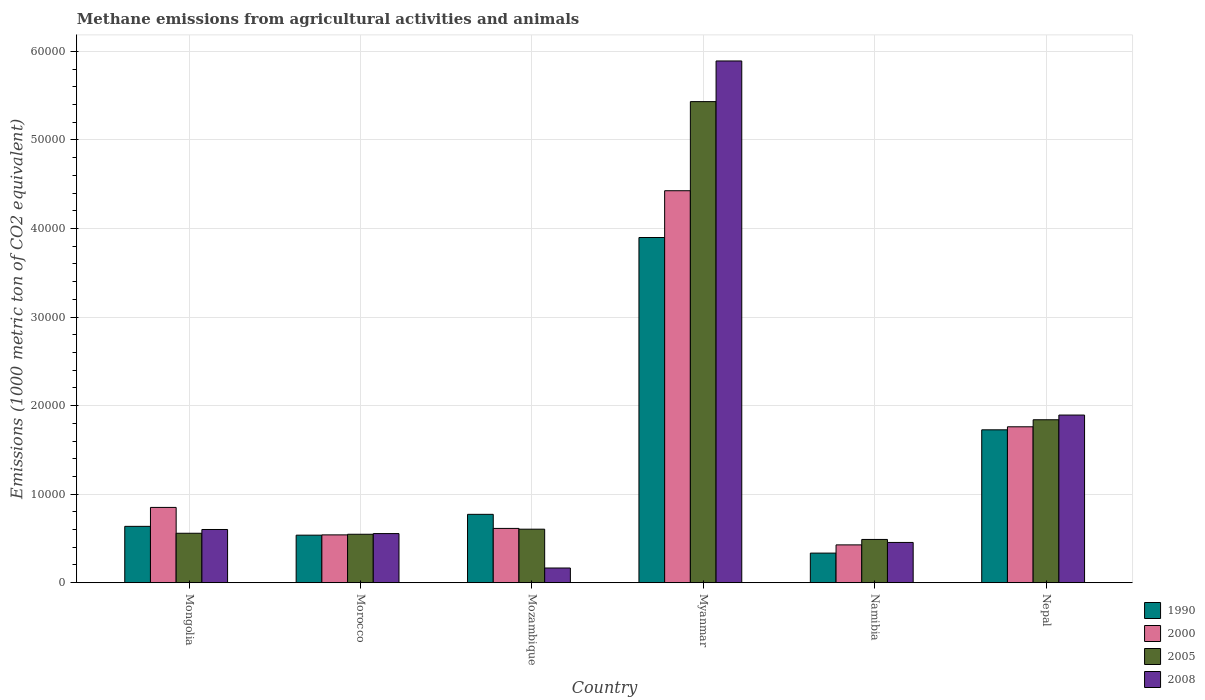How many different coloured bars are there?
Provide a succinct answer. 4. How many groups of bars are there?
Keep it short and to the point. 6. How many bars are there on the 3rd tick from the left?
Give a very brief answer. 4. What is the label of the 1st group of bars from the left?
Your response must be concise. Mongolia. What is the amount of methane emitted in 2008 in Mongolia?
Offer a terse response. 6009.3. Across all countries, what is the maximum amount of methane emitted in 2008?
Keep it short and to the point. 5.89e+04. Across all countries, what is the minimum amount of methane emitted in 1990?
Your answer should be very brief. 3344.1. In which country was the amount of methane emitted in 1990 maximum?
Your response must be concise. Myanmar. In which country was the amount of methane emitted in 1990 minimum?
Your response must be concise. Namibia. What is the total amount of methane emitted in 2000 in the graph?
Keep it short and to the point. 8.62e+04. What is the difference between the amount of methane emitted in 2005 in Morocco and that in Namibia?
Your answer should be very brief. 586. What is the difference between the amount of methane emitted in 2005 in Mongolia and the amount of methane emitted in 2000 in Myanmar?
Make the answer very short. -3.87e+04. What is the average amount of methane emitted in 1990 per country?
Keep it short and to the point. 1.32e+04. What is the difference between the amount of methane emitted of/in 2005 and amount of methane emitted of/in 1990 in Mozambique?
Provide a succinct answer. -1677.5. What is the ratio of the amount of methane emitted in 2000 in Mongolia to that in Myanmar?
Ensure brevity in your answer.  0.19. What is the difference between the highest and the second highest amount of methane emitted in 1990?
Make the answer very short. 9542.8. What is the difference between the highest and the lowest amount of methane emitted in 2008?
Provide a succinct answer. 5.73e+04. In how many countries, is the amount of methane emitted in 2008 greater than the average amount of methane emitted in 2008 taken over all countries?
Your answer should be compact. 2. Is the sum of the amount of methane emitted in 2000 in Myanmar and Nepal greater than the maximum amount of methane emitted in 1990 across all countries?
Provide a short and direct response. Yes. Is it the case that in every country, the sum of the amount of methane emitted in 2005 and amount of methane emitted in 2008 is greater than the sum of amount of methane emitted in 1990 and amount of methane emitted in 2000?
Provide a short and direct response. No. What does the 1st bar from the right in Morocco represents?
Offer a terse response. 2008. Is it the case that in every country, the sum of the amount of methane emitted in 2005 and amount of methane emitted in 1990 is greater than the amount of methane emitted in 2000?
Offer a terse response. Yes. How many bars are there?
Give a very brief answer. 24. How many countries are there in the graph?
Offer a terse response. 6. What is the difference between two consecutive major ticks on the Y-axis?
Provide a short and direct response. 10000. Does the graph contain grids?
Ensure brevity in your answer.  Yes. Where does the legend appear in the graph?
Your response must be concise. Bottom right. How are the legend labels stacked?
Keep it short and to the point. Vertical. What is the title of the graph?
Provide a succinct answer. Methane emissions from agricultural activities and animals. Does "1984" appear as one of the legend labels in the graph?
Your answer should be compact. No. What is the label or title of the X-axis?
Keep it short and to the point. Country. What is the label or title of the Y-axis?
Your response must be concise. Emissions (1000 metric ton of CO2 equivalent). What is the Emissions (1000 metric ton of CO2 equivalent) in 1990 in Mongolia?
Ensure brevity in your answer.  6363.5. What is the Emissions (1000 metric ton of CO2 equivalent) of 2000 in Mongolia?
Give a very brief answer. 8502.3. What is the Emissions (1000 metric ton of CO2 equivalent) of 2005 in Mongolia?
Your response must be concise. 5584.9. What is the Emissions (1000 metric ton of CO2 equivalent) of 2008 in Mongolia?
Provide a succinct answer. 6009.3. What is the Emissions (1000 metric ton of CO2 equivalent) in 1990 in Morocco?
Your response must be concise. 5368.8. What is the Emissions (1000 metric ton of CO2 equivalent) of 2000 in Morocco?
Keep it short and to the point. 5400.3. What is the Emissions (1000 metric ton of CO2 equivalent) in 2005 in Morocco?
Your response must be concise. 5471.4. What is the Emissions (1000 metric ton of CO2 equivalent) of 2008 in Morocco?
Keep it short and to the point. 5546.4. What is the Emissions (1000 metric ton of CO2 equivalent) of 1990 in Mozambique?
Your answer should be very brief. 7721.4. What is the Emissions (1000 metric ton of CO2 equivalent) in 2000 in Mozambique?
Provide a succinct answer. 6130.9. What is the Emissions (1000 metric ton of CO2 equivalent) in 2005 in Mozambique?
Your answer should be very brief. 6043.9. What is the Emissions (1000 metric ton of CO2 equivalent) in 2008 in Mozambique?
Make the answer very short. 1659.3. What is the Emissions (1000 metric ton of CO2 equivalent) in 1990 in Myanmar?
Make the answer very short. 3.90e+04. What is the Emissions (1000 metric ton of CO2 equivalent) of 2000 in Myanmar?
Your answer should be very brief. 4.43e+04. What is the Emissions (1000 metric ton of CO2 equivalent) in 2005 in Myanmar?
Ensure brevity in your answer.  5.43e+04. What is the Emissions (1000 metric ton of CO2 equivalent) of 2008 in Myanmar?
Offer a very short reply. 5.89e+04. What is the Emissions (1000 metric ton of CO2 equivalent) in 1990 in Namibia?
Make the answer very short. 3344.1. What is the Emissions (1000 metric ton of CO2 equivalent) of 2000 in Namibia?
Provide a short and direct response. 4271.2. What is the Emissions (1000 metric ton of CO2 equivalent) of 2005 in Namibia?
Provide a short and direct response. 4885.4. What is the Emissions (1000 metric ton of CO2 equivalent) in 2008 in Namibia?
Your answer should be compact. 4545.9. What is the Emissions (1000 metric ton of CO2 equivalent) of 1990 in Nepal?
Give a very brief answer. 1.73e+04. What is the Emissions (1000 metric ton of CO2 equivalent) of 2000 in Nepal?
Provide a succinct answer. 1.76e+04. What is the Emissions (1000 metric ton of CO2 equivalent) of 2005 in Nepal?
Ensure brevity in your answer.  1.84e+04. What is the Emissions (1000 metric ton of CO2 equivalent) of 2008 in Nepal?
Make the answer very short. 1.89e+04. Across all countries, what is the maximum Emissions (1000 metric ton of CO2 equivalent) of 1990?
Give a very brief answer. 3.90e+04. Across all countries, what is the maximum Emissions (1000 metric ton of CO2 equivalent) of 2000?
Your answer should be compact. 4.43e+04. Across all countries, what is the maximum Emissions (1000 metric ton of CO2 equivalent) of 2005?
Provide a succinct answer. 5.43e+04. Across all countries, what is the maximum Emissions (1000 metric ton of CO2 equivalent) in 2008?
Your answer should be compact. 5.89e+04. Across all countries, what is the minimum Emissions (1000 metric ton of CO2 equivalent) of 1990?
Keep it short and to the point. 3344.1. Across all countries, what is the minimum Emissions (1000 metric ton of CO2 equivalent) in 2000?
Your response must be concise. 4271.2. Across all countries, what is the minimum Emissions (1000 metric ton of CO2 equivalent) in 2005?
Keep it short and to the point. 4885.4. Across all countries, what is the minimum Emissions (1000 metric ton of CO2 equivalent) of 2008?
Offer a terse response. 1659.3. What is the total Emissions (1000 metric ton of CO2 equivalent) of 1990 in the graph?
Your answer should be compact. 7.90e+04. What is the total Emissions (1000 metric ton of CO2 equivalent) in 2000 in the graph?
Offer a very short reply. 8.62e+04. What is the total Emissions (1000 metric ton of CO2 equivalent) of 2005 in the graph?
Provide a succinct answer. 9.47e+04. What is the total Emissions (1000 metric ton of CO2 equivalent) of 2008 in the graph?
Give a very brief answer. 9.56e+04. What is the difference between the Emissions (1000 metric ton of CO2 equivalent) of 1990 in Mongolia and that in Morocco?
Your answer should be compact. 994.7. What is the difference between the Emissions (1000 metric ton of CO2 equivalent) of 2000 in Mongolia and that in Morocco?
Offer a terse response. 3102. What is the difference between the Emissions (1000 metric ton of CO2 equivalent) of 2005 in Mongolia and that in Morocco?
Ensure brevity in your answer.  113.5. What is the difference between the Emissions (1000 metric ton of CO2 equivalent) in 2008 in Mongolia and that in Morocco?
Keep it short and to the point. 462.9. What is the difference between the Emissions (1000 metric ton of CO2 equivalent) of 1990 in Mongolia and that in Mozambique?
Your answer should be very brief. -1357.9. What is the difference between the Emissions (1000 metric ton of CO2 equivalent) of 2000 in Mongolia and that in Mozambique?
Provide a short and direct response. 2371.4. What is the difference between the Emissions (1000 metric ton of CO2 equivalent) in 2005 in Mongolia and that in Mozambique?
Make the answer very short. -459. What is the difference between the Emissions (1000 metric ton of CO2 equivalent) of 2008 in Mongolia and that in Mozambique?
Your response must be concise. 4350. What is the difference between the Emissions (1000 metric ton of CO2 equivalent) in 1990 in Mongolia and that in Myanmar?
Offer a very short reply. -3.26e+04. What is the difference between the Emissions (1000 metric ton of CO2 equivalent) of 2000 in Mongolia and that in Myanmar?
Ensure brevity in your answer.  -3.58e+04. What is the difference between the Emissions (1000 metric ton of CO2 equivalent) of 2005 in Mongolia and that in Myanmar?
Give a very brief answer. -4.87e+04. What is the difference between the Emissions (1000 metric ton of CO2 equivalent) in 2008 in Mongolia and that in Myanmar?
Your answer should be compact. -5.29e+04. What is the difference between the Emissions (1000 metric ton of CO2 equivalent) of 1990 in Mongolia and that in Namibia?
Make the answer very short. 3019.4. What is the difference between the Emissions (1000 metric ton of CO2 equivalent) in 2000 in Mongolia and that in Namibia?
Your answer should be very brief. 4231.1. What is the difference between the Emissions (1000 metric ton of CO2 equivalent) in 2005 in Mongolia and that in Namibia?
Give a very brief answer. 699.5. What is the difference between the Emissions (1000 metric ton of CO2 equivalent) of 2008 in Mongolia and that in Namibia?
Offer a very short reply. 1463.4. What is the difference between the Emissions (1000 metric ton of CO2 equivalent) of 1990 in Mongolia and that in Nepal?
Your answer should be compact. -1.09e+04. What is the difference between the Emissions (1000 metric ton of CO2 equivalent) of 2000 in Mongolia and that in Nepal?
Make the answer very short. -9103.7. What is the difference between the Emissions (1000 metric ton of CO2 equivalent) in 2005 in Mongolia and that in Nepal?
Give a very brief answer. -1.28e+04. What is the difference between the Emissions (1000 metric ton of CO2 equivalent) of 2008 in Mongolia and that in Nepal?
Provide a short and direct response. -1.29e+04. What is the difference between the Emissions (1000 metric ton of CO2 equivalent) in 1990 in Morocco and that in Mozambique?
Give a very brief answer. -2352.6. What is the difference between the Emissions (1000 metric ton of CO2 equivalent) in 2000 in Morocco and that in Mozambique?
Your response must be concise. -730.6. What is the difference between the Emissions (1000 metric ton of CO2 equivalent) of 2005 in Morocco and that in Mozambique?
Your answer should be very brief. -572.5. What is the difference between the Emissions (1000 metric ton of CO2 equivalent) in 2008 in Morocco and that in Mozambique?
Your answer should be compact. 3887.1. What is the difference between the Emissions (1000 metric ton of CO2 equivalent) of 1990 in Morocco and that in Myanmar?
Provide a succinct answer. -3.36e+04. What is the difference between the Emissions (1000 metric ton of CO2 equivalent) in 2000 in Morocco and that in Myanmar?
Provide a succinct answer. -3.89e+04. What is the difference between the Emissions (1000 metric ton of CO2 equivalent) of 2005 in Morocco and that in Myanmar?
Your answer should be very brief. -4.89e+04. What is the difference between the Emissions (1000 metric ton of CO2 equivalent) of 2008 in Morocco and that in Myanmar?
Your answer should be very brief. -5.34e+04. What is the difference between the Emissions (1000 metric ton of CO2 equivalent) in 1990 in Morocco and that in Namibia?
Provide a short and direct response. 2024.7. What is the difference between the Emissions (1000 metric ton of CO2 equivalent) in 2000 in Morocco and that in Namibia?
Provide a succinct answer. 1129.1. What is the difference between the Emissions (1000 metric ton of CO2 equivalent) in 2005 in Morocco and that in Namibia?
Your answer should be very brief. 586. What is the difference between the Emissions (1000 metric ton of CO2 equivalent) of 2008 in Morocco and that in Namibia?
Your response must be concise. 1000.5. What is the difference between the Emissions (1000 metric ton of CO2 equivalent) in 1990 in Morocco and that in Nepal?
Provide a short and direct response. -1.19e+04. What is the difference between the Emissions (1000 metric ton of CO2 equivalent) in 2000 in Morocco and that in Nepal?
Ensure brevity in your answer.  -1.22e+04. What is the difference between the Emissions (1000 metric ton of CO2 equivalent) in 2005 in Morocco and that in Nepal?
Offer a terse response. -1.29e+04. What is the difference between the Emissions (1000 metric ton of CO2 equivalent) of 2008 in Morocco and that in Nepal?
Your response must be concise. -1.34e+04. What is the difference between the Emissions (1000 metric ton of CO2 equivalent) in 1990 in Mozambique and that in Myanmar?
Your response must be concise. -3.13e+04. What is the difference between the Emissions (1000 metric ton of CO2 equivalent) of 2000 in Mozambique and that in Myanmar?
Give a very brief answer. -3.81e+04. What is the difference between the Emissions (1000 metric ton of CO2 equivalent) of 2005 in Mozambique and that in Myanmar?
Give a very brief answer. -4.83e+04. What is the difference between the Emissions (1000 metric ton of CO2 equivalent) in 2008 in Mozambique and that in Myanmar?
Give a very brief answer. -5.73e+04. What is the difference between the Emissions (1000 metric ton of CO2 equivalent) in 1990 in Mozambique and that in Namibia?
Keep it short and to the point. 4377.3. What is the difference between the Emissions (1000 metric ton of CO2 equivalent) of 2000 in Mozambique and that in Namibia?
Keep it short and to the point. 1859.7. What is the difference between the Emissions (1000 metric ton of CO2 equivalent) in 2005 in Mozambique and that in Namibia?
Make the answer very short. 1158.5. What is the difference between the Emissions (1000 metric ton of CO2 equivalent) of 2008 in Mozambique and that in Namibia?
Provide a short and direct response. -2886.6. What is the difference between the Emissions (1000 metric ton of CO2 equivalent) in 1990 in Mozambique and that in Nepal?
Your answer should be compact. -9542.8. What is the difference between the Emissions (1000 metric ton of CO2 equivalent) of 2000 in Mozambique and that in Nepal?
Make the answer very short. -1.15e+04. What is the difference between the Emissions (1000 metric ton of CO2 equivalent) of 2005 in Mozambique and that in Nepal?
Your answer should be very brief. -1.24e+04. What is the difference between the Emissions (1000 metric ton of CO2 equivalent) in 2008 in Mozambique and that in Nepal?
Ensure brevity in your answer.  -1.73e+04. What is the difference between the Emissions (1000 metric ton of CO2 equivalent) in 1990 in Myanmar and that in Namibia?
Your answer should be very brief. 3.56e+04. What is the difference between the Emissions (1000 metric ton of CO2 equivalent) in 2000 in Myanmar and that in Namibia?
Ensure brevity in your answer.  4.00e+04. What is the difference between the Emissions (1000 metric ton of CO2 equivalent) of 2005 in Myanmar and that in Namibia?
Your response must be concise. 4.94e+04. What is the difference between the Emissions (1000 metric ton of CO2 equivalent) in 2008 in Myanmar and that in Namibia?
Provide a succinct answer. 5.44e+04. What is the difference between the Emissions (1000 metric ton of CO2 equivalent) of 1990 in Myanmar and that in Nepal?
Offer a very short reply. 2.17e+04. What is the difference between the Emissions (1000 metric ton of CO2 equivalent) in 2000 in Myanmar and that in Nepal?
Your response must be concise. 2.67e+04. What is the difference between the Emissions (1000 metric ton of CO2 equivalent) of 2005 in Myanmar and that in Nepal?
Keep it short and to the point. 3.59e+04. What is the difference between the Emissions (1000 metric ton of CO2 equivalent) in 2008 in Myanmar and that in Nepal?
Make the answer very short. 4.00e+04. What is the difference between the Emissions (1000 metric ton of CO2 equivalent) of 1990 in Namibia and that in Nepal?
Make the answer very short. -1.39e+04. What is the difference between the Emissions (1000 metric ton of CO2 equivalent) in 2000 in Namibia and that in Nepal?
Give a very brief answer. -1.33e+04. What is the difference between the Emissions (1000 metric ton of CO2 equivalent) in 2005 in Namibia and that in Nepal?
Provide a succinct answer. -1.35e+04. What is the difference between the Emissions (1000 metric ton of CO2 equivalent) in 2008 in Namibia and that in Nepal?
Provide a short and direct response. -1.44e+04. What is the difference between the Emissions (1000 metric ton of CO2 equivalent) in 1990 in Mongolia and the Emissions (1000 metric ton of CO2 equivalent) in 2000 in Morocco?
Your answer should be very brief. 963.2. What is the difference between the Emissions (1000 metric ton of CO2 equivalent) of 1990 in Mongolia and the Emissions (1000 metric ton of CO2 equivalent) of 2005 in Morocco?
Offer a very short reply. 892.1. What is the difference between the Emissions (1000 metric ton of CO2 equivalent) in 1990 in Mongolia and the Emissions (1000 metric ton of CO2 equivalent) in 2008 in Morocco?
Keep it short and to the point. 817.1. What is the difference between the Emissions (1000 metric ton of CO2 equivalent) of 2000 in Mongolia and the Emissions (1000 metric ton of CO2 equivalent) of 2005 in Morocco?
Offer a terse response. 3030.9. What is the difference between the Emissions (1000 metric ton of CO2 equivalent) of 2000 in Mongolia and the Emissions (1000 metric ton of CO2 equivalent) of 2008 in Morocco?
Offer a terse response. 2955.9. What is the difference between the Emissions (1000 metric ton of CO2 equivalent) of 2005 in Mongolia and the Emissions (1000 metric ton of CO2 equivalent) of 2008 in Morocco?
Your response must be concise. 38.5. What is the difference between the Emissions (1000 metric ton of CO2 equivalent) in 1990 in Mongolia and the Emissions (1000 metric ton of CO2 equivalent) in 2000 in Mozambique?
Ensure brevity in your answer.  232.6. What is the difference between the Emissions (1000 metric ton of CO2 equivalent) of 1990 in Mongolia and the Emissions (1000 metric ton of CO2 equivalent) of 2005 in Mozambique?
Your answer should be compact. 319.6. What is the difference between the Emissions (1000 metric ton of CO2 equivalent) in 1990 in Mongolia and the Emissions (1000 metric ton of CO2 equivalent) in 2008 in Mozambique?
Your answer should be very brief. 4704.2. What is the difference between the Emissions (1000 metric ton of CO2 equivalent) of 2000 in Mongolia and the Emissions (1000 metric ton of CO2 equivalent) of 2005 in Mozambique?
Provide a succinct answer. 2458.4. What is the difference between the Emissions (1000 metric ton of CO2 equivalent) in 2000 in Mongolia and the Emissions (1000 metric ton of CO2 equivalent) in 2008 in Mozambique?
Provide a short and direct response. 6843. What is the difference between the Emissions (1000 metric ton of CO2 equivalent) of 2005 in Mongolia and the Emissions (1000 metric ton of CO2 equivalent) of 2008 in Mozambique?
Your response must be concise. 3925.6. What is the difference between the Emissions (1000 metric ton of CO2 equivalent) of 1990 in Mongolia and the Emissions (1000 metric ton of CO2 equivalent) of 2000 in Myanmar?
Provide a short and direct response. -3.79e+04. What is the difference between the Emissions (1000 metric ton of CO2 equivalent) of 1990 in Mongolia and the Emissions (1000 metric ton of CO2 equivalent) of 2005 in Myanmar?
Your response must be concise. -4.80e+04. What is the difference between the Emissions (1000 metric ton of CO2 equivalent) of 1990 in Mongolia and the Emissions (1000 metric ton of CO2 equivalent) of 2008 in Myanmar?
Offer a very short reply. -5.26e+04. What is the difference between the Emissions (1000 metric ton of CO2 equivalent) in 2000 in Mongolia and the Emissions (1000 metric ton of CO2 equivalent) in 2005 in Myanmar?
Your answer should be compact. -4.58e+04. What is the difference between the Emissions (1000 metric ton of CO2 equivalent) of 2000 in Mongolia and the Emissions (1000 metric ton of CO2 equivalent) of 2008 in Myanmar?
Give a very brief answer. -5.04e+04. What is the difference between the Emissions (1000 metric ton of CO2 equivalent) in 2005 in Mongolia and the Emissions (1000 metric ton of CO2 equivalent) in 2008 in Myanmar?
Your answer should be compact. -5.33e+04. What is the difference between the Emissions (1000 metric ton of CO2 equivalent) of 1990 in Mongolia and the Emissions (1000 metric ton of CO2 equivalent) of 2000 in Namibia?
Provide a succinct answer. 2092.3. What is the difference between the Emissions (1000 metric ton of CO2 equivalent) of 1990 in Mongolia and the Emissions (1000 metric ton of CO2 equivalent) of 2005 in Namibia?
Offer a terse response. 1478.1. What is the difference between the Emissions (1000 metric ton of CO2 equivalent) of 1990 in Mongolia and the Emissions (1000 metric ton of CO2 equivalent) of 2008 in Namibia?
Make the answer very short. 1817.6. What is the difference between the Emissions (1000 metric ton of CO2 equivalent) of 2000 in Mongolia and the Emissions (1000 metric ton of CO2 equivalent) of 2005 in Namibia?
Offer a very short reply. 3616.9. What is the difference between the Emissions (1000 metric ton of CO2 equivalent) of 2000 in Mongolia and the Emissions (1000 metric ton of CO2 equivalent) of 2008 in Namibia?
Keep it short and to the point. 3956.4. What is the difference between the Emissions (1000 metric ton of CO2 equivalent) in 2005 in Mongolia and the Emissions (1000 metric ton of CO2 equivalent) in 2008 in Namibia?
Provide a short and direct response. 1039. What is the difference between the Emissions (1000 metric ton of CO2 equivalent) of 1990 in Mongolia and the Emissions (1000 metric ton of CO2 equivalent) of 2000 in Nepal?
Keep it short and to the point. -1.12e+04. What is the difference between the Emissions (1000 metric ton of CO2 equivalent) in 1990 in Mongolia and the Emissions (1000 metric ton of CO2 equivalent) in 2005 in Nepal?
Ensure brevity in your answer.  -1.20e+04. What is the difference between the Emissions (1000 metric ton of CO2 equivalent) in 1990 in Mongolia and the Emissions (1000 metric ton of CO2 equivalent) in 2008 in Nepal?
Your answer should be compact. -1.26e+04. What is the difference between the Emissions (1000 metric ton of CO2 equivalent) in 2000 in Mongolia and the Emissions (1000 metric ton of CO2 equivalent) in 2005 in Nepal?
Keep it short and to the point. -9897. What is the difference between the Emissions (1000 metric ton of CO2 equivalent) of 2000 in Mongolia and the Emissions (1000 metric ton of CO2 equivalent) of 2008 in Nepal?
Offer a very short reply. -1.04e+04. What is the difference between the Emissions (1000 metric ton of CO2 equivalent) in 2005 in Mongolia and the Emissions (1000 metric ton of CO2 equivalent) in 2008 in Nepal?
Keep it short and to the point. -1.33e+04. What is the difference between the Emissions (1000 metric ton of CO2 equivalent) in 1990 in Morocco and the Emissions (1000 metric ton of CO2 equivalent) in 2000 in Mozambique?
Provide a succinct answer. -762.1. What is the difference between the Emissions (1000 metric ton of CO2 equivalent) in 1990 in Morocco and the Emissions (1000 metric ton of CO2 equivalent) in 2005 in Mozambique?
Your answer should be compact. -675.1. What is the difference between the Emissions (1000 metric ton of CO2 equivalent) of 1990 in Morocco and the Emissions (1000 metric ton of CO2 equivalent) of 2008 in Mozambique?
Ensure brevity in your answer.  3709.5. What is the difference between the Emissions (1000 metric ton of CO2 equivalent) of 2000 in Morocco and the Emissions (1000 metric ton of CO2 equivalent) of 2005 in Mozambique?
Your answer should be very brief. -643.6. What is the difference between the Emissions (1000 metric ton of CO2 equivalent) of 2000 in Morocco and the Emissions (1000 metric ton of CO2 equivalent) of 2008 in Mozambique?
Provide a short and direct response. 3741. What is the difference between the Emissions (1000 metric ton of CO2 equivalent) in 2005 in Morocco and the Emissions (1000 metric ton of CO2 equivalent) in 2008 in Mozambique?
Provide a short and direct response. 3812.1. What is the difference between the Emissions (1000 metric ton of CO2 equivalent) in 1990 in Morocco and the Emissions (1000 metric ton of CO2 equivalent) in 2000 in Myanmar?
Ensure brevity in your answer.  -3.89e+04. What is the difference between the Emissions (1000 metric ton of CO2 equivalent) of 1990 in Morocco and the Emissions (1000 metric ton of CO2 equivalent) of 2005 in Myanmar?
Your answer should be very brief. -4.90e+04. What is the difference between the Emissions (1000 metric ton of CO2 equivalent) in 1990 in Morocco and the Emissions (1000 metric ton of CO2 equivalent) in 2008 in Myanmar?
Provide a succinct answer. -5.35e+04. What is the difference between the Emissions (1000 metric ton of CO2 equivalent) of 2000 in Morocco and the Emissions (1000 metric ton of CO2 equivalent) of 2005 in Myanmar?
Your answer should be compact. -4.89e+04. What is the difference between the Emissions (1000 metric ton of CO2 equivalent) of 2000 in Morocco and the Emissions (1000 metric ton of CO2 equivalent) of 2008 in Myanmar?
Provide a succinct answer. -5.35e+04. What is the difference between the Emissions (1000 metric ton of CO2 equivalent) of 2005 in Morocco and the Emissions (1000 metric ton of CO2 equivalent) of 2008 in Myanmar?
Provide a short and direct response. -5.34e+04. What is the difference between the Emissions (1000 metric ton of CO2 equivalent) in 1990 in Morocco and the Emissions (1000 metric ton of CO2 equivalent) in 2000 in Namibia?
Provide a short and direct response. 1097.6. What is the difference between the Emissions (1000 metric ton of CO2 equivalent) of 1990 in Morocco and the Emissions (1000 metric ton of CO2 equivalent) of 2005 in Namibia?
Your answer should be very brief. 483.4. What is the difference between the Emissions (1000 metric ton of CO2 equivalent) of 1990 in Morocco and the Emissions (1000 metric ton of CO2 equivalent) of 2008 in Namibia?
Keep it short and to the point. 822.9. What is the difference between the Emissions (1000 metric ton of CO2 equivalent) in 2000 in Morocco and the Emissions (1000 metric ton of CO2 equivalent) in 2005 in Namibia?
Keep it short and to the point. 514.9. What is the difference between the Emissions (1000 metric ton of CO2 equivalent) of 2000 in Morocco and the Emissions (1000 metric ton of CO2 equivalent) of 2008 in Namibia?
Your response must be concise. 854.4. What is the difference between the Emissions (1000 metric ton of CO2 equivalent) in 2005 in Morocco and the Emissions (1000 metric ton of CO2 equivalent) in 2008 in Namibia?
Give a very brief answer. 925.5. What is the difference between the Emissions (1000 metric ton of CO2 equivalent) of 1990 in Morocco and the Emissions (1000 metric ton of CO2 equivalent) of 2000 in Nepal?
Offer a very short reply. -1.22e+04. What is the difference between the Emissions (1000 metric ton of CO2 equivalent) in 1990 in Morocco and the Emissions (1000 metric ton of CO2 equivalent) in 2005 in Nepal?
Provide a succinct answer. -1.30e+04. What is the difference between the Emissions (1000 metric ton of CO2 equivalent) of 1990 in Morocco and the Emissions (1000 metric ton of CO2 equivalent) of 2008 in Nepal?
Keep it short and to the point. -1.36e+04. What is the difference between the Emissions (1000 metric ton of CO2 equivalent) of 2000 in Morocco and the Emissions (1000 metric ton of CO2 equivalent) of 2005 in Nepal?
Provide a short and direct response. -1.30e+04. What is the difference between the Emissions (1000 metric ton of CO2 equivalent) in 2000 in Morocco and the Emissions (1000 metric ton of CO2 equivalent) in 2008 in Nepal?
Provide a succinct answer. -1.35e+04. What is the difference between the Emissions (1000 metric ton of CO2 equivalent) in 2005 in Morocco and the Emissions (1000 metric ton of CO2 equivalent) in 2008 in Nepal?
Your response must be concise. -1.35e+04. What is the difference between the Emissions (1000 metric ton of CO2 equivalent) of 1990 in Mozambique and the Emissions (1000 metric ton of CO2 equivalent) of 2000 in Myanmar?
Ensure brevity in your answer.  -3.65e+04. What is the difference between the Emissions (1000 metric ton of CO2 equivalent) in 1990 in Mozambique and the Emissions (1000 metric ton of CO2 equivalent) in 2005 in Myanmar?
Offer a very short reply. -4.66e+04. What is the difference between the Emissions (1000 metric ton of CO2 equivalent) in 1990 in Mozambique and the Emissions (1000 metric ton of CO2 equivalent) in 2008 in Myanmar?
Offer a very short reply. -5.12e+04. What is the difference between the Emissions (1000 metric ton of CO2 equivalent) in 2000 in Mozambique and the Emissions (1000 metric ton of CO2 equivalent) in 2005 in Myanmar?
Your answer should be compact. -4.82e+04. What is the difference between the Emissions (1000 metric ton of CO2 equivalent) of 2000 in Mozambique and the Emissions (1000 metric ton of CO2 equivalent) of 2008 in Myanmar?
Give a very brief answer. -5.28e+04. What is the difference between the Emissions (1000 metric ton of CO2 equivalent) in 2005 in Mozambique and the Emissions (1000 metric ton of CO2 equivalent) in 2008 in Myanmar?
Give a very brief answer. -5.29e+04. What is the difference between the Emissions (1000 metric ton of CO2 equivalent) in 1990 in Mozambique and the Emissions (1000 metric ton of CO2 equivalent) in 2000 in Namibia?
Provide a short and direct response. 3450.2. What is the difference between the Emissions (1000 metric ton of CO2 equivalent) of 1990 in Mozambique and the Emissions (1000 metric ton of CO2 equivalent) of 2005 in Namibia?
Provide a succinct answer. 2836. What is the difference between the Emissions (1000 metric ton of CO2 equivalent) of 1990 in Mozambique and the Emissions (1000 metric ton of CO2 equivalent) of 2008 in Namibia?
Offer a terse response. 3175.5. What is the difference between the Emissions (1000 metric ton of CO2 equivalent) of 2000 in Mozambique and the Emissions (1000 metric ton of CO2 equivalent) of 2005 in Namibia?
Your answer should be compact. 1245.5. What is the difference between the Emissions (1000 metric ton of CO2 equivalent) in 2000 in Mozambique and the Emissions (1000 metric ton of CO2 equivalent) in 2008 in Namibia?
Your answer should be compact. 1585. What is the difference between the Emissions (1000 metric ton of CO2 equivalent) of 2005 in Mozambique and the Emissions (1000 metric ton of CO2 equivalent) of 2008 in Namibia?
Give a very brief answer. 1498. What is the difference between the Emissions (1000 metric ton of CO2 equivalent) of 1990 in Mozambique and the Emissions (1000 metric ton of CO2 equivalent) of 2000 in Nepal?
Offer a terse response. -9884.6. What is the difference between the Emissions (1000 metric ton of CO2 equivalent) of 1990 in Mozambique and the Emissions (1000 metric ton of CO2 equivalent) of 2005 in Nepal?
Offer a terse response. -1.07e+04. What is the difference between the Emissions (1000 metric ton of CO2 equivalent) in 1990 in Mozambique and the Emissions (1000 metric ton of CO2 equivalent) in 2008 in Nepal?
Keep it short and to the point. -1.12e+04. What is the difference between the Emissions (1000 metric ton of CO2 equivalent) of 2000 in Mozambique and the Emissions (1000 metric ton of CO2 equivalent) of 2005 in Nepal?
Offer a terse response. -1.23e+04. What is the difference between the Emissions (1000 metric ton of CO2 equivalent) in 2000 in Mozambique and the Emissions (1000 metric ton of CO2 equivalent) in 2008 in Nepal?
Provide a succinct answer. -1.28e+04. What is the difference between the Emissions (1000 metric ton of CO2 equivalent) in 2005 in Mozambique and the Emissions (1000 metric ton of CO2 equivalent) in 2008 in Nepal?
Make the answer very short. -1.29e+04. What is the difference between the Emissions (1000 metric ton of CO2 equivalent) of 1990 in Myanmar and the Emissions (1000 metric ton of CO2 equivalent) of 2000 in Namibia?
Provide a succinct answer. 3.47e+04. What is the difference between the Emissions (1000 metric ton of CO2 equivalent) of 1990 in Myanmar and the Emissions (1000 metric ton of CO2 equivalent) of 2005 in Namibia?
Ensure brevity in your answer.  3.41e+04. What is the difference between the Emissions (1000 metric ton of CO2 equivalent) of 1990 in Myanmar and the Emissions (1000 metric ton of CO2 equivalent) of 2008 in Namibia?
Offer a very short reply. 3.44e+04. What is the difference between the Emissions (1000 metric ton of CO2 equivalent) in 2000 in Myanmar and the Emissions (1000 metric ton of CO2 equivalent) in 2005 in Namibia?
Ensure brevity in your answer.  3.94e+04. What is the difference between the Emissions (1000 metric ton of CO2 equivalent) of 2000 in Myanmar and the Emissions (1000 metric ton of CO2 equivalent) of 2008 in Namibia?
Provide a short and direct response. 3.97e+04. What is the difference between the Emissions (1000 metric ton of CO2 equivalent) in 2005 in Myanmar and the Emissions (1000 metric ton of CO2 equivalent) in 2008 in Namibia?
Your answer should be compact. 4.98e+04. What is the difference between the Emissions (1000 metric ton of CO2 equivalent) in 1990 in Myanmar and the Emissions (1000 metric ton of CO2 equivalent) in 2000 in Nepal?
Make the answer very short. 2.14e+04. What is the difference between the Emissions (1000 metric ton of CO2 equivalent) of 1990 in Myanmar and the Emissions (1000 metric ton of CO2 equivalent) of 2005 in Nepal?
Give a very brief answer. 2.06e+04. What is the difference between the Emissions (1000 metric ton of CO2 equivalent) of 1990 in Myanmar and the Emissions (1000 metric ton of CO2 equivalent) of 2008 in Nepal?
Your answer should be compact. 2.00e+04. What is the difference between the Emissions (1000 metric ton of CO2 equivalent) in 2000 in Myanmar and the Emissions (1000 metric ton of CO2 equivalent) in 2005 in Nepal?
Give a very brief answer. 2.59e+04. What is the difference between the Emissions (1000 metric ton of CO2 equivalent) in 2000 in Myanmar and the Emissions (1000 metric ton of CO2 equivalent) in 2008 in Nepal?
Provide a short and direct response. 2.53e+04. What is the difference between the Emissions (1000 metric ton of CO2 equivalent) in 2005 in Myanmar and the Emissions (1000 metric ton of CO2 equivalent) in 2008 in Nepal?
Provide a short and direct response. 3.54e+04. What is the difference between the Emissions (1000 metric ton of CO2 equivalent) in 1990 in Namibia and the Emissions (1000 metric ton of CO2 equivalent) in 2000 in Nepal?
Your answer should be compact. -1.43e+04. What is the difference between the Emissions (1000 metric ton of CO2 equivalent) in 1990 in Namibia and the Emissions (1000 metric ton of CO2 equivalent) in 2005 in Nepal?
Give a very brief answer. -1.51e+04. What is the difference between the Emissions (1000 metric ton of CO2 equivalent) of 1990 in Namibia and the Emissions (1000 metric ton of CO2 equivalent) of 2008 in Nepal?
Offer a terse response. -1.56e+04. What is the difference between the Emissions (1000 metric ton of CO2 equivalent) of 2000 in Namibia and the Emissions (1000 metric ton of CO2 equivalent) of 2005 in Nepal?
Make the answer very short. -1.41e+04. What is the difference between the Emissions (1000 metric ton of CO2 equivalent) in 2000 in Namibia and the Emissions (1000 metric ton of CO2 equivalent) in 2008 in Nepal?
Your response must be concise. -1.47e+04. What is the difference between the Emissions (1000 metric ton of CO2 equivalent) in 2005 in Namibia and the Emissions (1000 metric ton of CO2 equivalent) in 2008 in Nepal?
Provide a succinct answer. -1.40e+04. What is the average Emissions (1000 metric ton of CO2 equivalent) in 1990 per country?
Keep it short and to the point. 1.32e+04. What is the average Emissions (1000 metric ton of CO2 equivalent) of 2000 per country?
Offer a very short reply. 1.44e+04. What is the average Emissions (1000 metric ton of CO2 equivalent) of 2005 per country?
Your answer should be very brief. 1.58e+04. What is the average Emissions (1000 metric ton of CO2 equivalent) in 2008 per country?
Make the answer very short. 1.59e+04. What is the difference between the Emissions (1000 metric ton of CO2 equivalent) in 1990 and Emissions (1000 metric ton of CO2 equivalent) in 2000 in Mongolia?
Your response must be concise. -2138.8. What is the difference between the Emissions (1000 metric ton of CO2 equivalent) of 1990 and Emissions (1000 metric ton of CO2 equivalent) of 2005 in Mongolia?
Your answer should be very brief. 778.6. What is the difference between the Emissions (1000 metric ton of CO2 equivalent) of 1990 and Emissions (1000 metric ton of CO2 equivalent) of 2008 in Mongolia?
Provide a short and direct response. 354.2. What is the difference between the Emissions (1000 metric ton of CO2 equivalent) in 2000 and Emissions (1000 metric ton of CO2 equivalent) in 2005 in Mongolia?
Your answer should be very brief. 2917.4. What is the difference between the Emissions (1000 metric ton of CO2 equivalent) of 2000 and Emissions (1000 metric ton of CO2 equivalent) of 2008 in Mongolia?
Provide a succinct answer. 2493. What is the difference between the Emissions (1000 metric ton of CO2 equivalent) in 2005 and Emissions (1000 metric ton of CO2 equivalent) in 2008 in Mongolia?
Give a very brief answer. -424.4. What is the difference between the Emissions (1000 metric ton of CO2 equivalent) in 1990 and Emissions (1000 metric ton of CO2 equivalent) in 2000 in Morocco?
Your answer should be very brief. -31.5. What is the difference between the Emissions (1000 metric ton of CO2 equivalent) in 1990 and Emissions (1000 metric ton of CO2 equivalent) in 2005 in Morocco?
Provide a succinct answer. -102.6. What is the difference between the Emissions (1000 metric ton of CO2 equivalent) in 1990 and Emissions (1000 metric ton of CO2 equivalent) in 2008 in Morocco?
Your response must be concise. -177.6. What is the difference between the Emissions (1000 metric ton of CO2 equivalent) of 2000 and Emissions (1000 metric ton of CO2 equivalent) of 2005 in Morocco?
Ensure brevity in your answer.  -71.1. What is the difference between the Emissions (1000 metric ton of CO2 equivalent) of 2000 and Emissions (1000 metric ton of CO2 equivalent) of 2008 in Morocco?
Offer a very short reply. -146.1. What is the difference between the Emissions (1000 metric ton of CO2 equivalent) of 2005 and Emissions (1000 metric ton of CO2 equivalent) of 2008 in Morocco?
Offer a very short reply. -75. What is the difference between the Emissions (1000 metric ton of CO2 equivalent) in 1990 and Emissions (1000 metric ton of CO2 equivalent) in 2000 in Mozambique?
Your answer should be compact. 1590.5. What is the difference between the Emissions (1000 metric ton of CO2 equivalent) in 1990 and Emissions (1000 metric ton of CO2 equivalent) in 2005 in Mozambique?
Keep it short and to the point. 1677.5. What is the difference between the Emissions (1000 metric ton of CO2 equivalent) in 1990 and Emissions (1000 metric ton of CO2 equivalent) in 2008 in Mozambique?
Make the answer very short. 6062.1. What is the difference between the Emissions (1000 metric ton of CO2 equivalent) in 2000 and Emissions (1000 metric ton of CO2 equivalent) in 2008 in Mozambique?
Give a very brief answer. 4471.6. What is the difference between the Emissions (1000 metric ton of CO2 equivalent) in 2005 and Emissions (1000 metric ton of CO2 equivalent) in 2008 in Mozambique?
Provide a succinct answer. 4384.6. What is the difference between the Emissions (1000 metric ton of CO2 equivalent) of 1990 and Emissions (1000 metric ton of CO2 equivalent) of 2000 in Myanmar?
Ensure brevity in your answer.  -5282. What is the difference between the Emissions (1000 metric ton of CO2 equivalent) of 1990 and Emissions (1000 metric ton of CO2 equivalent) of 2005 in Myanmar?
Keep it short and to the point. -1.53e+04. What is the difference between the Emissions (1000 metric ton of CO2 equivalent) in 1990 and Emissions (1000 metric ton of CO2 equivalent) in 2008 in Myanmar?
Your answer should be very brief. -1.99e+04. What is the difference between the Emissions (1000 metric ton of CO2 equivalent) of 2000 and Emissions (1000 metric ton of CO2 equivalent) of 2005 in Myanmar?
Your answer should be compact. -1.01e+04. What is the difference between the Emissions (1000 metric ton of CO2 equivalent) in 2000 and Emissions (1000 metric ton of CO2 equivalent) in 2008 in Myanmar?
Give a very brief answer. -1.47e+04. What is the difference between the Emissions (1000 metric ton of CO2 equivalent) in 2005 and Emissions (1000 metric ton of CO2 equivalent) in 2008 in Myanmar?
Ensure brevity in your answer.  -4589.9. What is the difference between the Emissions (1000 metric ton of CO2 equivalent) in 1990 and Emissions (1000 metric ton of CO2 equivalent) in 2000 in Namibia?
Offer a very short reply. -927.1. What is the difference between the Emissions (1000 metric ton of CO2 equivalent) in 1990 and Emissions (1000 metric ton of CO2 equivalent) in 2005 in Namibia?
Make the answer very short. -1541.3. What is the difference between the Emissions (1000 metric ton of CO2 equivalent) in 1990 and Emissions (1000 metric ton of CO2 equivalent) in 2008 in Namibia?
Your response must be concise. -1201.8. What is the difference between the Emissions (1000 metric ton of CO2 equivalent) in 2000 and Emissions (1000 metric ton of CO2 equivalent) in 2005 in Namibia?
Provide a short and direct response. -614.2. What is the difference between the Emissions (1000 metric ton of CO2 equivalent) in 2000 and Emissions (1000 metric ton of CO2 equivalent) in 2008 in Namibia?
Your response must be concise. -274.7. What is the difference between the Emissions (1000 metric ton of CO2 equivalent) of 2005 and Emissions (1000 metric ton of CO2 equivalent) of 2008 in Namibia?
Provide a succinct answer. 339.5. What is the difference between the Emissions (1000 metric ton of CO2 equivalent) in 1990 and Emissions (1000 metric ton of CO2 equivalent) in 2000 in Nepal?
Your answer should be compact. -341.8. What is the difference between the Emissions (1000 metric ton of CO2 equivalent) in 1990 and Emissions (1000 metric ton of CO2 equivalent) in 2005 in Nepal?
Your answer should be very brief. -1135.1. What is the difference between the Emissions (1000 metric ton of CO2 equivalent) in 1990 and Emissions (1000 metric ton of CO2 equivalent) in 2008 in Nepal?
Keep it short and to the point. -1666.2. What is the difference between the Emissions (1000 metric ton of CO2 equivalent) of 2000 and Emissions (1000 metric ton of CO2 equivalent) of 2005 in Nepal?
Your response must be concise. -793.3. What is the difference between the Emissions (1000 metric ton of CO2 equivalent) in 2000 and Emissions (1000 metric ton of CO2 equivalent) in 2008 in Nepal?
Ensure brevity in your answer.  -1324.4. What is the difference between the Emissions (1000 metric ton of CO2 equivalent) of 2005 and Emissions (1000 metric ton of CO2 equivalent) of 2008 in Nepal?
Provide a succinct answer. -531.1. What is the ratio of the Emissions (1000 metric ton of CO2 equivalent) in 1990 in Mongolia to that in Morocco?
Make the answer very short. 1.19. What is the ratio of the Emissions (1000 metric ton of CO2 equivalent) in 2000 in Mongolia to that in Morocco?
Ensure brevity in your answer.  1.57. What is the ratio of the Emissions (1000 metric ton of CO2 equivalent) in 2005 in Mongolia to that in Morocco?
Your answer should be very brief. 1.02. What is the ratio of the Emissions (1000 metric ton of CO2 equivalent) in 2008 in Mongolia to that in Morocco?
Offer a terse response. 1.08. What is the ratio of the Emissions (1000 metric ton of CO2 equivalent) of 1990 in Mongolia to that in Mozambique?
Your answer should be very brief. 0.82. What is the ratio of the Emissions (1000 metric ton of CO2 equivalent) of 2000 in Mongolia to that in Mozambique?
Offer a terse response. 1.39. What is the ratio of the Emissions (1000 metric ton of CO2 equivalent) in 2005 in Mongolia to that in Mozambique?
Provide a succinct answer. 0.92. What is the ratio of the Emissions (1000 metric ton of CO2 equivalent) of 2008 in Mongolia to that in Mozambique?
Offer a terse response. 3.62. What is the ratio of the Emissions (1000 metric ton of CO2 equivalent) of 1990 in Mongolia to that in Myanmar?
Provide a short and direct response. 0.16. What is the ratio of the Emissions (1000 metric ton of CO2 equivalent) in 2000 in Mongolia to that in Myanmar?
Your answer should be compact. 0.19. What is the ratio of the Emissions (1000 metric ton of CO2 equivalent) of 2005 in Mongolia to that in Myanmar?
Provide a succinct answer. 0.1. What is the ratio of the Emissions (1000 metric ton of CO2 equivalent) in 2008 in Mongolia to that in Myanmar?
Offer a very short reply. 0.1. What is the ratio of the Emissions (1000 metric ton of CO2 equivalent) in 1990 in Mongolia to that in Namibia?
Your response must be concise. 1.9. What is the ratio of the Emissions (1000 metric ton of CO2 equivalent) in 2000 in Mongolia to that in Namibia?
Keep it short and to the point. 1.99. What is the ratio of the Emissions (1000 metric ton of CO2 equivalent) of 2005 in Mongolia to that in Namibia?
Give a very brief answer. 1.14. What is the ratio of the Emissions (1000 metric ton of CO2 equivalent) in 2008 in Mongolia to that in Namibia?
Ensure brevity in your answer.  1.32. What is the ratio of the Emissions (1000 metric ton of CO2 equivalent) in 1990 in Mongolia to that in Nepal?
Your response must be concise. 0.37. What is the ratio of the Emissions (1000 metric ton of CO2 equivalent) in 2000 in Mongolia to that in Nepal?
Offer a terse response. 0.48. What is the ratio of the Emissions (1000 metric ton of CO2 equivalent) of 2005 in Mongolia to that in Nepal?
Offer a terse response. 0.3. What is the ratio of the Emissions (1000 metric ton of CO2 equivalent) in 2008 in Mongolia to that in Nepal?
Offer a very short reply. 0.32. What is the ratio of the Emissions (1000 metric ton of CO2 equivalent) of 1990 in Morocco to that in Mozambique?
Your answer should be compact. 0.7. What is the ratio of the Emissions (1000 metric ton of CO2 equivalent) in 2000 in Morocco to that in Mozambique?
Ensure brevity in your answer.  0.88. What is the ratio of the Emissions (1000 metric ton of CO2 equivalent) in 2005 in Morocco to that in Mozambique?
Provide a succinct answer. 0.91. What is the ratio of the Emissions (1000 metric ton of CO2 equivalent) of 2008 in Morocco to that in Mozambique?
Offer a very short reply. 3.34. What is the ratio of the Emissions (1000 metric ton of CO2 equivalent) in 1990 in Morocco to that in Myanmar?
Your response must be concise. 0.14. What is the ratio of the Emissions (1000 metric ton of CO2 equivalent) of 2000 in Morocco to that in Myanmar?
Keep it short and to the point. 0.12. What is the ratio of the Emissions (1000 metric ton of CO2 equivalent) in 2005 in Morocco to that in Myanmar?
Offer a terse response. 0.1. What is the ratio of the Emissions (1000 metric ton of CO2 equivalent) in 2008 in Morocco to that in Myanmar?
Offer a terse response. 0.09. What is the ratio of the Emissions (1000 metric ton of CO2 equivalent) in 1990 in Morocco to that in Namibia?
Your response must be concise. 1.61. What is the ratio of the Emissions (1000 metric ton of CO2 equivalent) of 2000 in Morocco to that in Namibia?
Give a very brief answer. 1.26. What is the ratio of the Emissions (1000 metric ton of CO2 equivalent) of 2005 in Morocco to that in Namibia?
Provide a short and direct response. 1.12. What is the ratio of the Emissions (1000 metric ton of CO2 equivalent) in 2008 in Morocco to that in Namibia?
Keep it short and to the point. 1.22. What is the ratio of the Emissions (1000 metric ton of CO2 equivalent) in 1990 in Morocco to that in Nepal?
Provide a short and direct response. 0.31. What is the ratio of the Emissions (1000 metric ton of CO2 equivalent) in 2000 in Morocco to that in Nepal?
Your response must be concise. 0.31. What is the ratio of the Emissions (1000 metric ton of CO2 equivalent) of 2005 in Morocco to that in Nepal?
Ensure brevity in your answer.  0.3. What is the ratio of the Emissions (1000 metric ton of CO2 equivalent) of 2008 in Morocco to that in Nepal?
Offer a terse response. 0.29. What is the ratio of the Emissions (1000 metric ton of CO2 equivalent) of 1990 in Mozambique to that in Myanmar?
Offer a very short reply. 0.2. What is the ratio of the Emissions (1000 metric ton of CO2 equivalent) in 2000 in Mozambique to that in Myanmar?
Ensure brevity in your answer.  0.14. What is the ratio of the Emissions (1000 metric ton of CO2 equivalent) of 2005 in Mozambique to that in Myanmar?
Offer a terse response. 0.11. What is the ratio of the Emissions (1000 metric ton of CO2 equivalent) in 2008 in Mozambique to that in Myanmar?
Your answer should be compact. 0.03. What is the ratio of the Emissions (1000 metric ton of CO2 equivalent) in 1990 in Mozambique to that in Namibia?
Your answer should be very brief. 2.31. What is the ratio of the Emissions (1000 metric ton of CO2 equivalent) in 2000 in Mozambique to that in Namibia?
Your answer should be very brief. 1.44. What is the ratio of the Emissions (1000 metric ton of CO2 equivalent) in 2005 in Mozambique to that in Namibia?
Offer a very short reply. 1.24. What is the ratio of the Emissions (1000 metric ton of CO2 equivalent) of 2008 in Mozambique to that in Namibia?
Your answer should be compact. 0.36. What is the ratio of the Emissions (1000 metric ton of CO2 equivalent) in 1990 in Mozambique to that in Nepal?
Your answer should be compact. 0.45. What is the ratio of the Emissions (1000 metric ton of CO2 equivalent) in 2000 in Mozambique to that in Nepal?
Give a very brief answer. 0.35. What is the ratio of the Emissions (1000 metric ton of CO2 equivalent) in 2005 in Mozambique to that in Nepal?
Provide a succinct answer. 0.33. What is the ratio of the Emissions (1000 metric ton of CO2 equivalent) of 2008 in Mozambique to that in Nepal?
Ensure brevity in your answer.  0.09. What is the ratio of the Emissions (1000 metric ton of CO2 equivalent) of 1990 in Myanmar to that in Namibia?
Provide a short and direct response. 11.66. What is the ratio of the Emissions (1000 metric ton of CO2 equivalent) of 2000 in Myanmar to that in Namibia?
Offer a terse response. 10.36. What is the ratio of the Emissions (1000 metric ton of CO2 equivalent) in 2005 in Myanmar to that in Namibia?
Make the answer very short. 11.12. What is the ratio of the Emissions (1000 metric ton of CO2 equivalent) in 2008 in Myanmar to that in Namibia?
Ensure brevity in your answer.  12.96. What is the ratio of the Emissions (1000 metric ton of CO2 equivalent) of 1990 in Myanmar to that in Nepal?
Your response must be concise. 2.26. What is the ratio of the Emissions (1000 metric ton of CO2 equivalent) in 2000 in Myanmar to that in Nepal?
Your answer should be very brief. 2.51. What is the ratio of the Emissions (1000 metric ton of CO2 equivalent) in 2005 in Myanmar to that in Nepal?
Your response must be concise. 2.95. What is the ratio of the Emissions (1000 metric ton of CO2 equivalent) of 2008 in Myanmar to that in Nepal?
Offer a very short reply. 3.11. What is the ratio of the Emissions (1000 metric ton of CO2 equivalent) in 1990 in Namibia to that in Nepal?
Provide a succinct answer. 0.19. What is the ratio of the Emissions (1000 metric ton of CO2 equivalent) of 2000 in Namibia to that in Nepal?
Offer a terse response. 0.24. What is the ratio of the Emissions (1000 metric ton of CO2 equivalent) in 2005 in Namibia to that in Nepal?
Give a very brief answer. 0.27. What is the ratio of the Emissions (1000 metric ton of CO2 equivalent) in 2008 in Namibia to that in Nepal?
Keep it short and to the point. 0.24. What is the difference between the highest and the second highest Emissions (1000 metric ton of CO2 equivalent) in 1990?
Give a very brief answer. 2.17e+04. What is the difference between the highest and the second highest Emissions (1000 metric ton of CO2 equivalent) of 2000?
Your response must be concise. 2.67e+04. What is the difference between the highest and the second highest Emissions (1000 metric ton of CO2 equivalent) in 2005?
Provide a succinct answer. 3.59e+04. What is the difference between the highest and the second highest Emissions (1000 metric ton of CO2 equivalent) of 2008?
Your answer should be very brief. 4.00e+04. What is the difference between the highest and the lowest Emissions (1000 metric ton of CO2 equivalent) of 1990?
Keep it short and to the point. 3.56e+04. What is the difference between the highest and the lowest Emissions (1000 metric ton of CO2 equivalent) in 2000?
Your answer should be compact. 4.00e+04. What is the difference between the highest and the lowest Emissions (1000 metric ton of CO2 equivalent) in 2005?
Provide a succinct answer. 4.94e+04. What is the difference between the highest and the lowest Emissions (1000 metric ton of CO2 equivalent) in 2008?
Your response must be concise. 5.73e+04. 